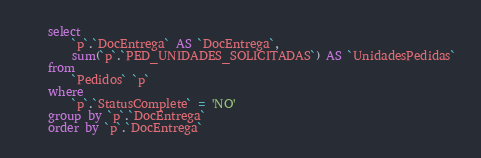<code> <loc_0><loc_0><loc_500><loc_500><_SQL_>    select 
        `p`.`DocEntrega` AS `DocEntrega`,
        sum(`p`.`PED_UNIDADES_SOLICITADAS`) AS `UnidadesPedidas`
    from
        `Pedidos` `p`
    where
        `p`.`StatusComplete` = 'NO'
    group by `p`.`DocEntrega`
    order by `p`.`DocEntrega`</code> 